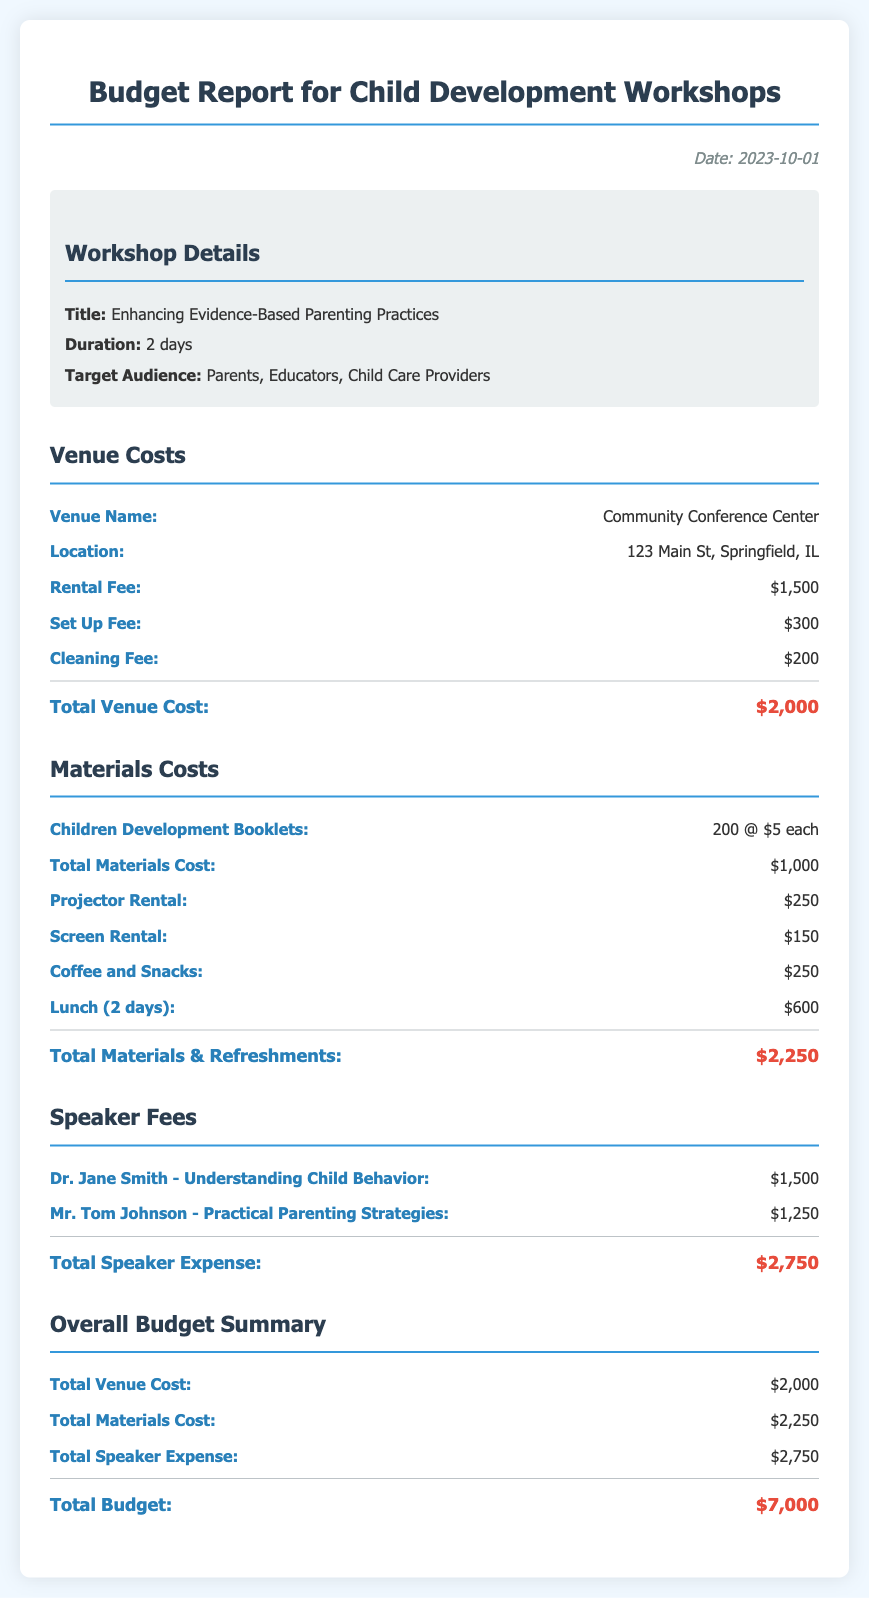What is the title of the workshop? The title of the workshop is provided in the document under the workshop details section.
Answer: Enhancing Evidence-Based Parenting Practices What is the total venue cost? The total venue cost is detailed in the budget section specifically for venue costs.
Answer: $2,000 Who is the speaker for "Understanding Child Behavior"? The document lists speakers and their topics; this is one of the specific inquiries that can be found there.
Answer: Dr. Jane Smith What is the total speaker expense? Total speaker expense can be summarized from the budget section that outlines all speaker fees.
Answer: $2,750 How many children development booklets are included? The document specifies the quantity of booklets under materials costs.
Answer: 200 What is the cleaning fee for the venue? The cleaning fee is explicitly stated in the venue costs section of the budget.
Answer: $200 What is the total budget for the workshop? The total budget can be found in the overall budget summary section which sums up all costs.
Answer: $7,000 What are the coffee and snacks costs? The document specifies the cost for coffee and snacks in the materials costs section.
Answer: $250 What is the location of the workshop? The location is mentioned in the venue costs section of the budget report.
Answer: 123 Main St, Springfield, IL 